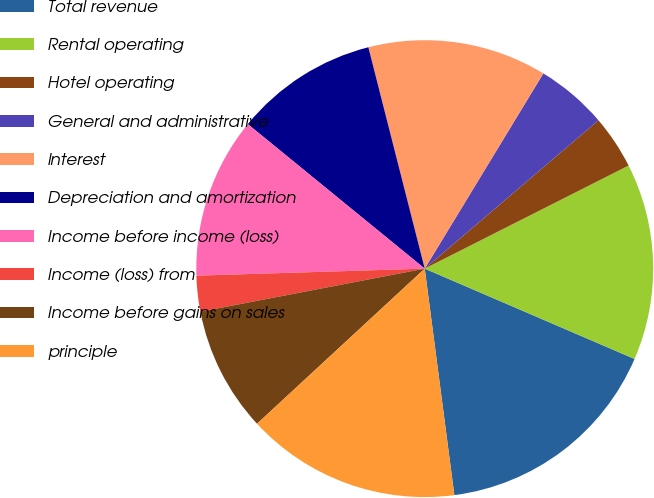Convert chart to OTSL. <chart><loc_0><loc_0><loc_500><loc_500><pie_chart><fcel>Total revenue<fcel>Rental operating<fcel>Hotel operating<fcel>General and administrative<fcel>Interest<fcel>Depreciation and amortization<fcel>Income before income (loss)<fcel>Income (loss) from<fcel>Income before gains on sales<fcel>principle<nl><fcel>16.46%<fcel>13.92%<fcel>3.8%<fcel>5.06%<fcel>12.66%<fcel>10.13%<fcel>11.39%<fcel>2.53%<fcel>8.86%<fcel>15.19%<nl></chart> 